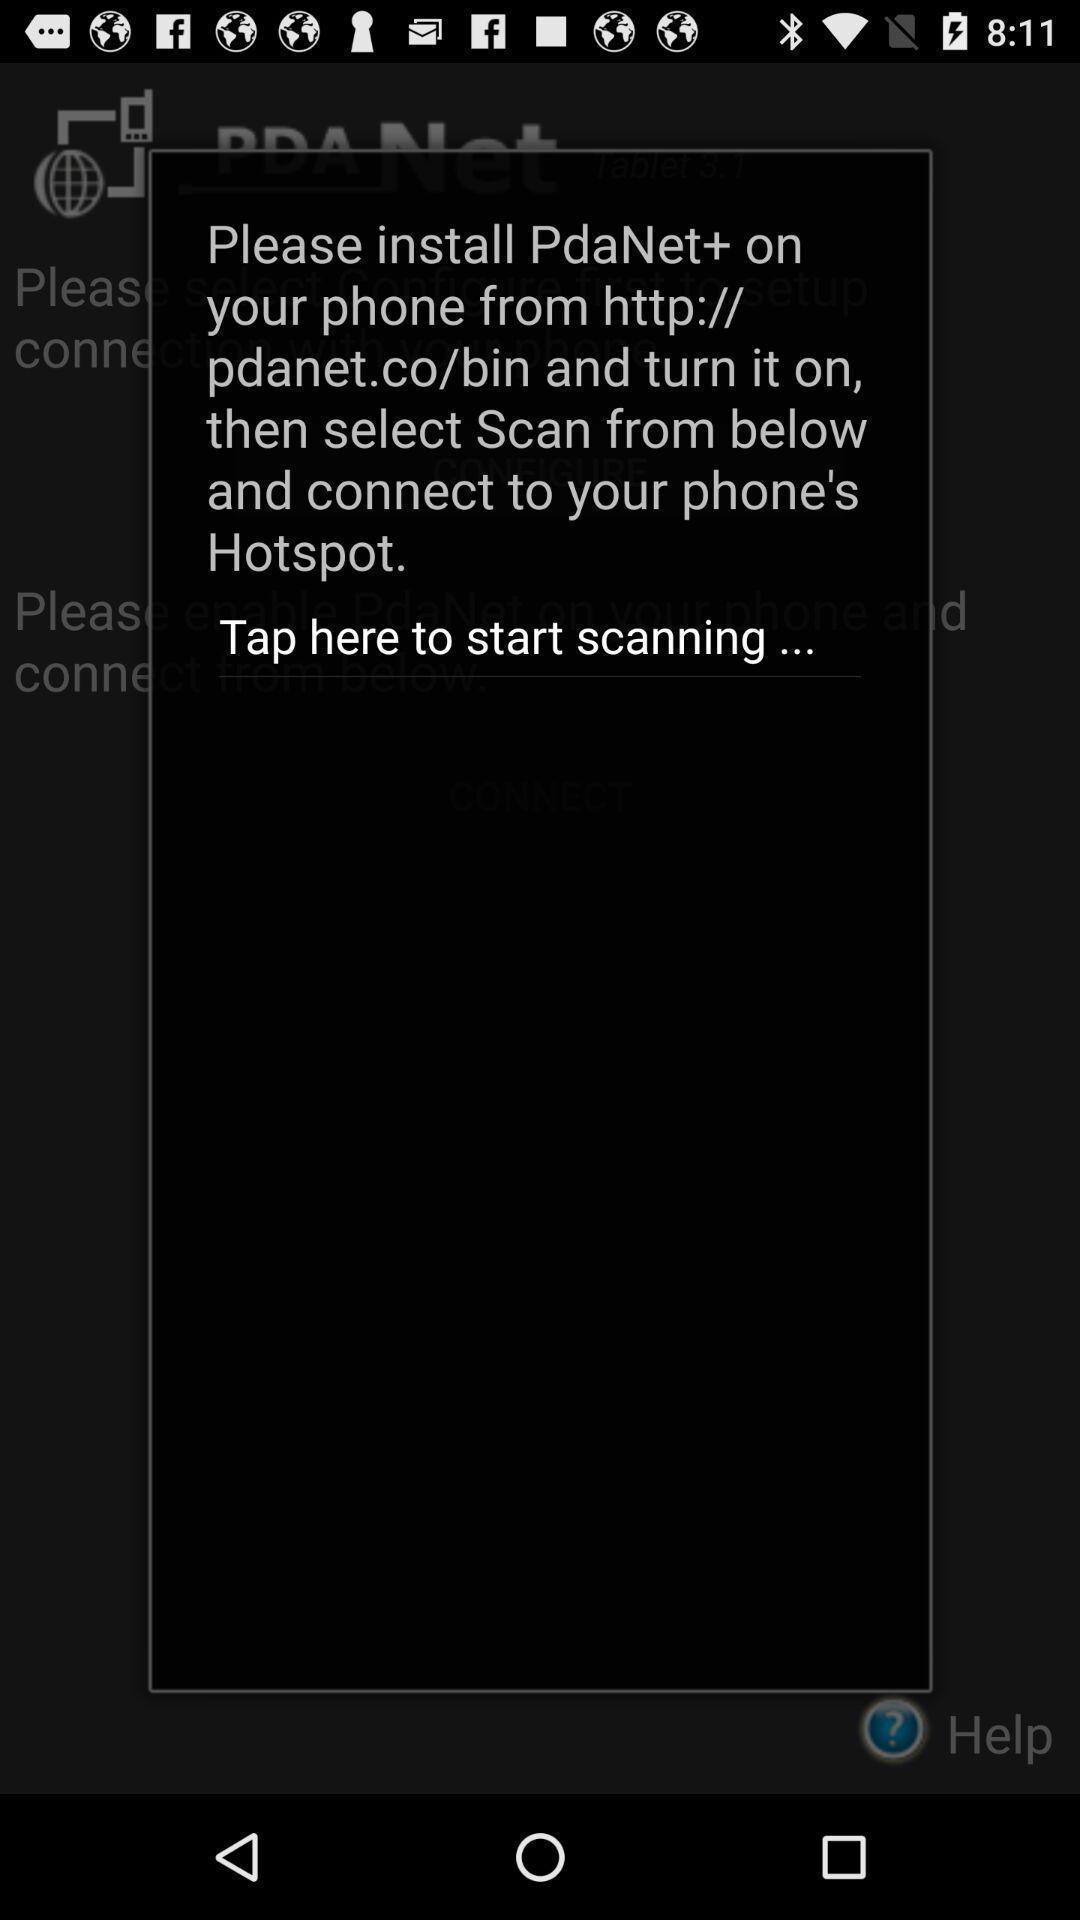What details can you identify in this image? Pop-up displaying information about application. 